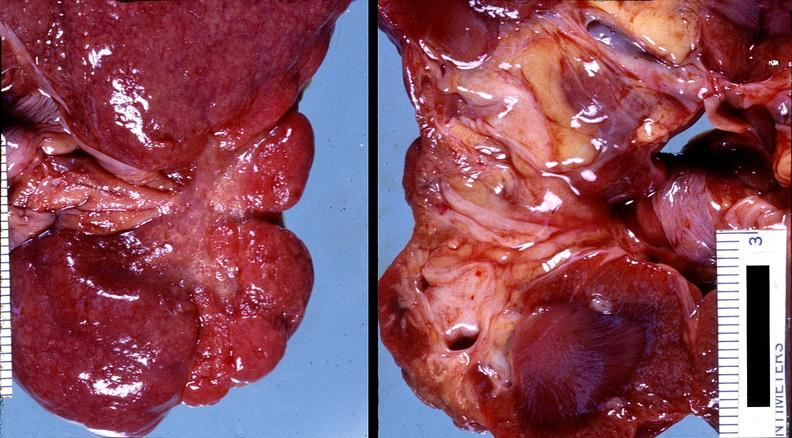does this image show kidney, pyelonephritis?
Answer the question using a single word or phrase. Yes 